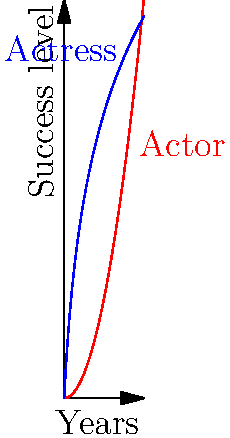Examine the graph depicting the career trajectories of an actor and an actress over a 10-year period. At what point in their careers does the actress's success level surpass that of the actor? What insights can be drawn about their relative career progressions? To determine when the actress's success surpasses the actor's, we need to analyze the two curves:

1. The red curve represents the actor's career, following a quadratic function: $f(x) = 0.5x^2$
2. The blue curve represents the actress's career, following a logarithmic function: $g(x) = 20\log(x+1)$

To find the intersection point, we need to solve the equation:

$0.5x^2 = 20\log(x+1)$

This equation cannot be solved algebraically, so we need to estimate visually or use numerical methods.

From the graph, we can see that the curves intersect at approximately $x = 3$ years.

Insights about their career progressions:
1. The actor's career starts slowly but accelerates over time (quadratic growth).
2. The actress's career has rapid initial growth but slows down over time (logarithmic growth).
3. In the early years (0-3), the actress's career progresses faster.
4. After the intersection point, the actor's career growth overtakes the actress's.
5. By the 10-year mark, the actor's success level is significantly higher than the actress's.

This pattern suggests that while the actress had early success, the actor's perseverance led to greater long-term success.
Answer: Approximately 3 years; actress has rapid early success, actor achieves greater long-term success. 